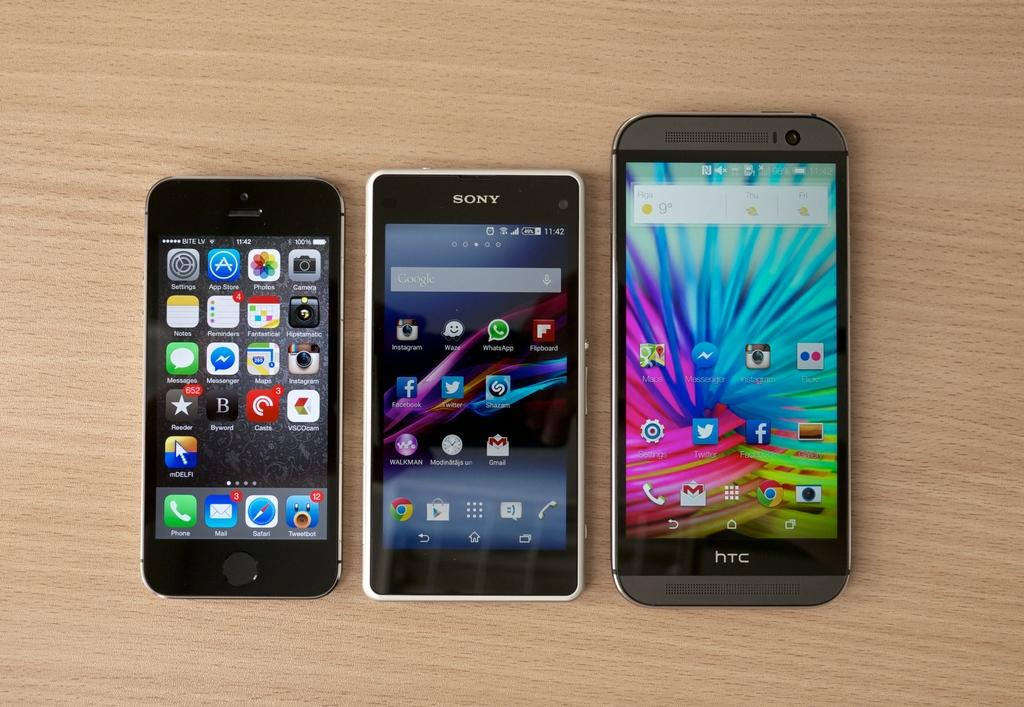<image>
Render a clear and concise summary of the photo. Three cell phones, one is an iPhone, the middle is a Sony brand, and the right one is a HTC. 